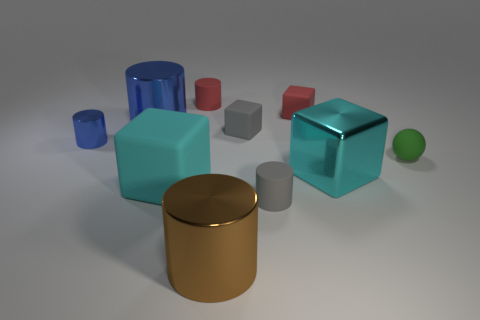Subtract all tiny blue cylinders. How many cylinders are left? 4 Subtract 1 cylinders. How many cylinders are left? 4 Subtract all blue blocks. How many blue cylinders are left? 2 Subtract all red cylinders. How many cylinders are left? 4 Add 4 big blue cylinders. How many big blue cylinders are left? 5 Add 1 blue rubber things. How many blue rubber things exist? 1 Subtract 1 red cylinders. How many objects are left? 9 Subtract all balls. How many objects are left? 9 Subtract all brown balls. Subtract all green cylinders. How many balls are left? 1 Subtract all blue objects. Subtract all small red blocks. How many objects are left? 7 